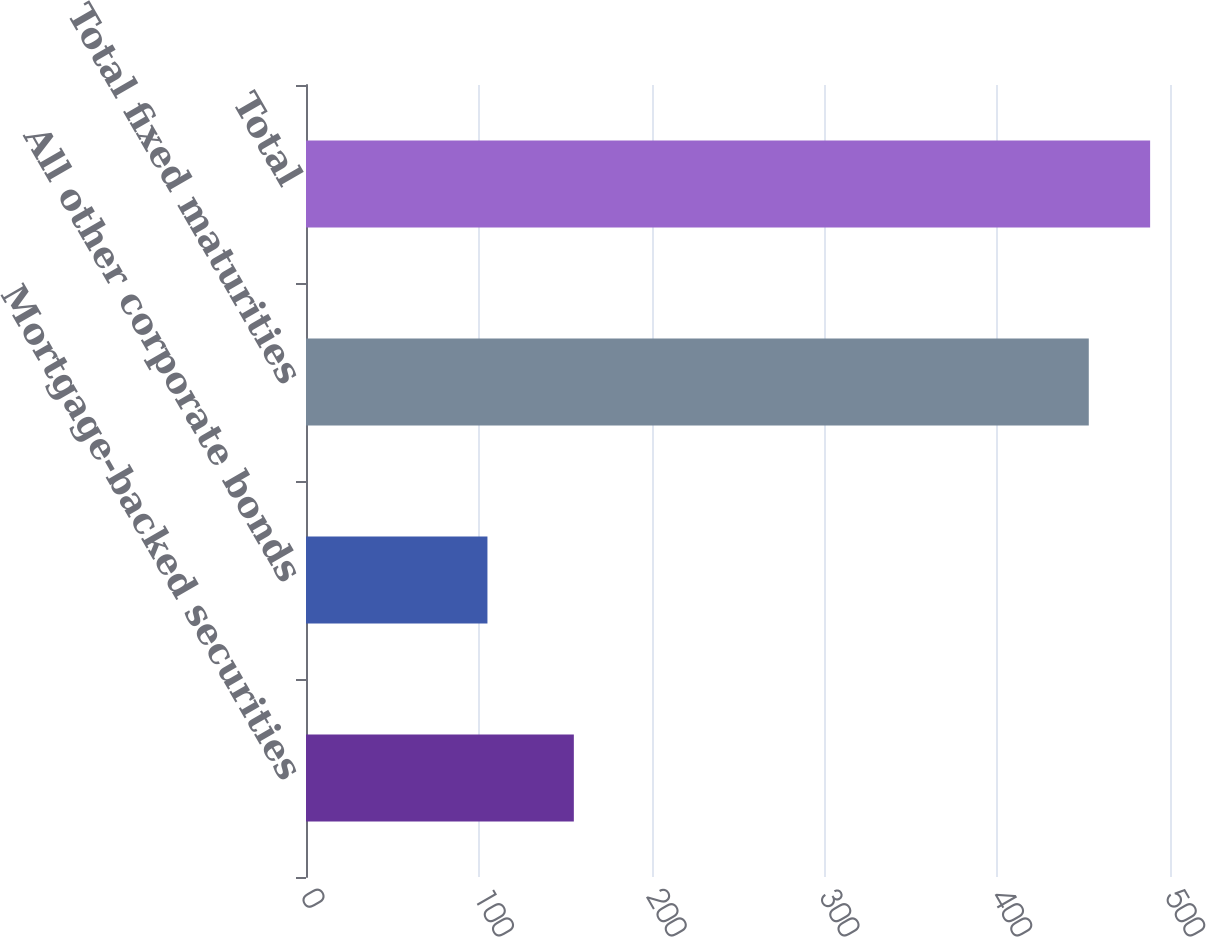Convert chart to OTSL. <chart><loc_0><loc_0><loc_500><loc_500><bar_chart><fcel>Mortgage-backed securities<fcel>All other corporate bonds<fcel>Total fixed maturities<fcel>Total<nl><fcel>155<fcel>105<fcel>453<fcel>488.5<nl></chart> 